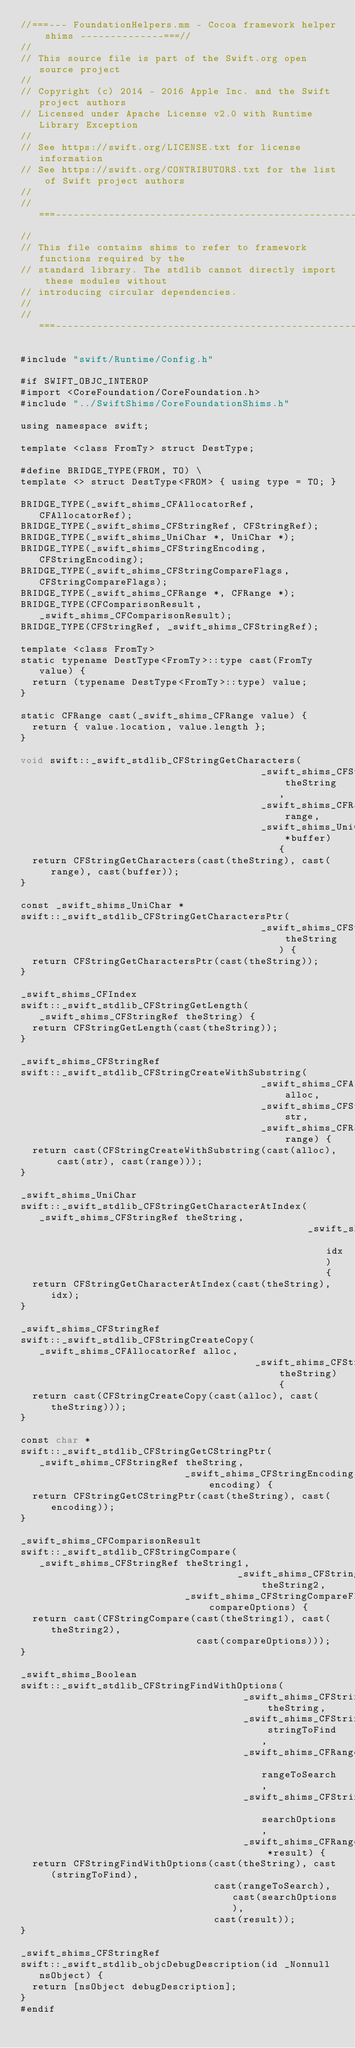<code> <loc_0><loc_0><loc_500><loc_500><_ObjectiveC_>//===--- FoundationHelpers.mm - Cocoa framework helper shims --------------===//
//
// This source file is part of the Swift.org open source project
//
// Copyright (c) 2014 - 2016 Apple Inc. and the Swift project authors
// Licensed under Apache License v2.0 with Runtime Library Exception
//
// See https://swift.org/LICENSE.txt for license information
// See https://swift.org/CONTRIBUTORS.txt for the list of Swift project authors
//
//===----------------------------------------------------------------------===//
//
// This file contains shims to refer to framework functions required by the
// standard library. The stdlib cannot directly import these modules without
// introducing circular dependencies.
//
//===----------------------------------------------------------------------===//

#include "swift/Runtime/Config.h"

#if SWIFT_OBJC_INTEROP
#import <CoreFoundation/CoreFoundation.h>
#include "../SwiftShims/CoreFoundationShims.h"

using namespace swift;

template <class FromTy> struct DestType;

#define BRIDGE_TYPE(FROM, TO) \
template <> struct DestType<FROM> { using type = TO; }

BRIDGE_TYPE(_swift_shims_CFAllocatorRef, CFAllocatorRef);
BRIDGE_TYPE(_swift_shims_CFStringRef, CFStringRef);
BRIDGE_TYPE(_swift_shims_UniChar *, UniChar *);
BRIDGE_TYPE(_swift_shims_CFStringEncoding, CFStringEncoding);
BRIDGE_TYPE(_swift_shims_CFStringCompareFlags, CFStringCompareFlags);
BRIDGE_TYPE(_swift_shims_CFRange *, CFRange *);
BRIDGE_TYPE(CFComparisonResult, _swift_shims_CFComparisonResult);
BRIDGE_TYPE(CFStringRef, _swift_shims_CFStringRef);

template <class FromTy>
static typename DestType<FromTy>::type cast(FromTy value) {
  return (typename DestType<FromTy>::type) value;
}

static CFRange cast(_swift_shims_CFRange value) {
  return { value.location, value.length };
}

void swift::_swift_stdlib_CFStringGetCharacters(
                                         _swift_shims_CFStringRef theString,
                                         _swift_shims_CFRange range,
                                         _swift_shims_UniChar *buffer) {
  return CFStringGetCharacters(cast(theString), cast(range), cast(buffer));
}

const _swift_shims_UniChar *
swift::_swift_stdlib_CFStringGetCharactersPtr(
                                         _swift_shims_CFStringRef theString) {
  return CFStringGetCharactersPtr(cast(theString));
}

_swift_shims_CFIndex
swift::_swift_stdlib_CFStringGetLength(_swift_shims_CFStringRef theString) {
  return CFStringGetLength(cast(theString));
}

_swift_shims_CFStringRef
swift::_swift_stdlib_CFStringCreateWithSubstring(
                                         _swift_shims_CFAllocatorRef alloc,
                                         _swift_shims_CFStringRef str,
                                         _swift_shims_CFRange range) {
  return cast(CFStringCreateWithSubstring(cast(alloc), cast(str), cast(range)));
}

_swift_shims_UniChar
swift::_swift_stdlib_CFStringGetCharacterAtIndex(_swift_shims_CFStringRef theString,
                                                 _swift_shims_CFIndex idx) {
  return CFStringGetCharacterAtIndex(cast(theString), idx);
}

_swift_shims_CFStringRef
swift::_swift_stdlib_CFStringCreateCopy(_swift_shims_CFAllocatorRef alloc,
                                        _swift_shims_CFStringRef theString) {
  return cast(CFStringCreateCopy(cast(alloc), cast(theString)));
}

const char *
swift::_swift_stdlib_CFStringGetCStringPtr(_swift_shims_CFStringRef theString,
                            _swift_shims_CFStringEncoding encoding) {
  return CFStringGetCStringPtr(cast(theString), cast(encoding));
}

_swift_shims_CFComparisonResult
swift::_swift_stdlib_CFStringCompare(_swift_shims_CFStringRef theString1,
                                     _swift_shims_CFStringRef theString2,
                            _swift_shims_CFStringCompareFlags compareOptions) {
  return cast(CFStringCompare(cast(theString1), cast(theString2),
                              cast(compareOptions)));
}

_swift_shims_Boolean
swift::_swift_stdlib_CFStringFindWithOptions(
                                      _swift_shims_CFStringRef theString,
                                      _swift_shims_CFStringRef stringToFind,
                                      _swift_shims_CFRange rangeToSearch,
                                      _swift_shims_CFStringCompareFlags searchOptions,
                                      _swift_shims_CFRange *result) {
  return CFStringFindWithOptions(cast(theString), cast(stringToFind),
                                 cast(rangeToSearch), cast(searchOptions),
                                 cast(result));
}

_swift_shims_CFStringRef
swift::_swift_stdlib_objcDebugDescription(id _Nonnull nsObject) {
  return [nsObject debugDescription];
}
#endif

</code> 